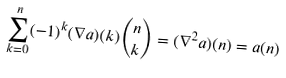Convert formula to latex. <formula><loc_0><loc_0><loc_500><loc_500>\sum _ { k = 0 } ^ { n } ( - 1 ) ^ { k } ( \nabla a ) ( k ) \binom { n } { k } = ( \nabla ^ { 2 } a ) ( n ) = a ( n )</formula> 